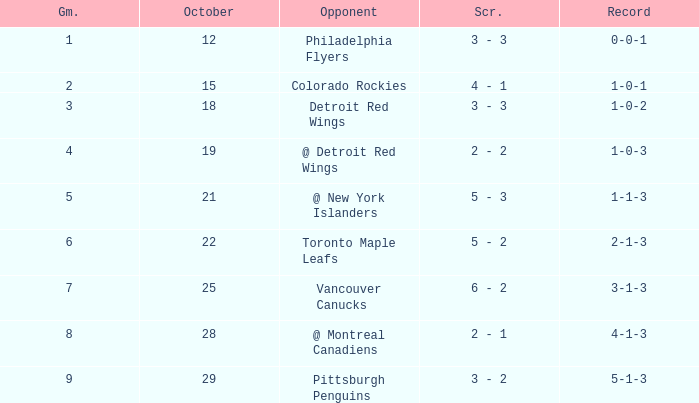Name the score for game more than 6 and before october 28 6 - 2. 